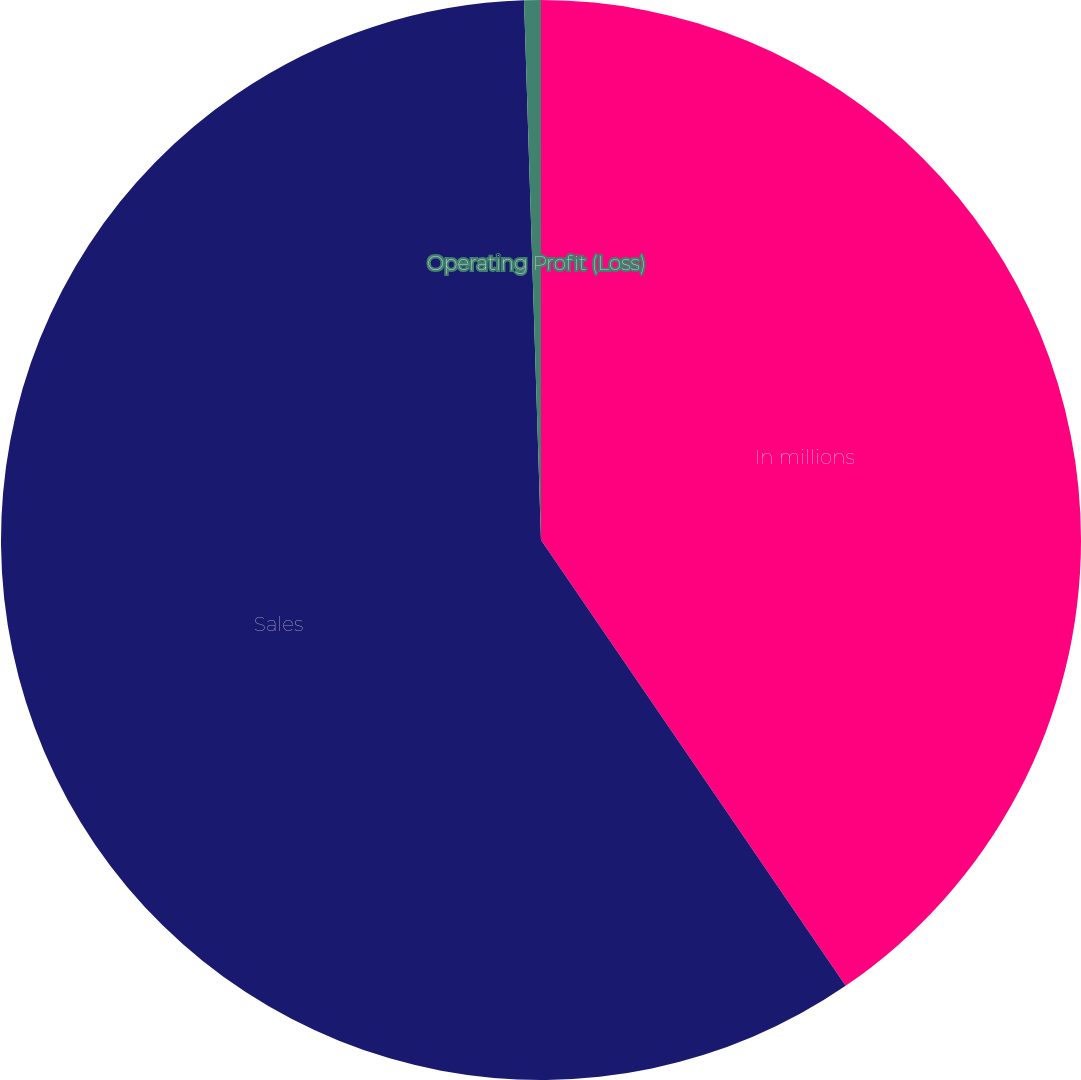Convert chart to OTSL. <chart><loc_0><loc_0><loc_500><loc_500><pie_chart><fcel>In millions<fcel>Sales<fcel>Operating Profit (Loss)<nl><fcel>40.46%<fcel>59.04%<fcel>0.5%<nl></chart> 